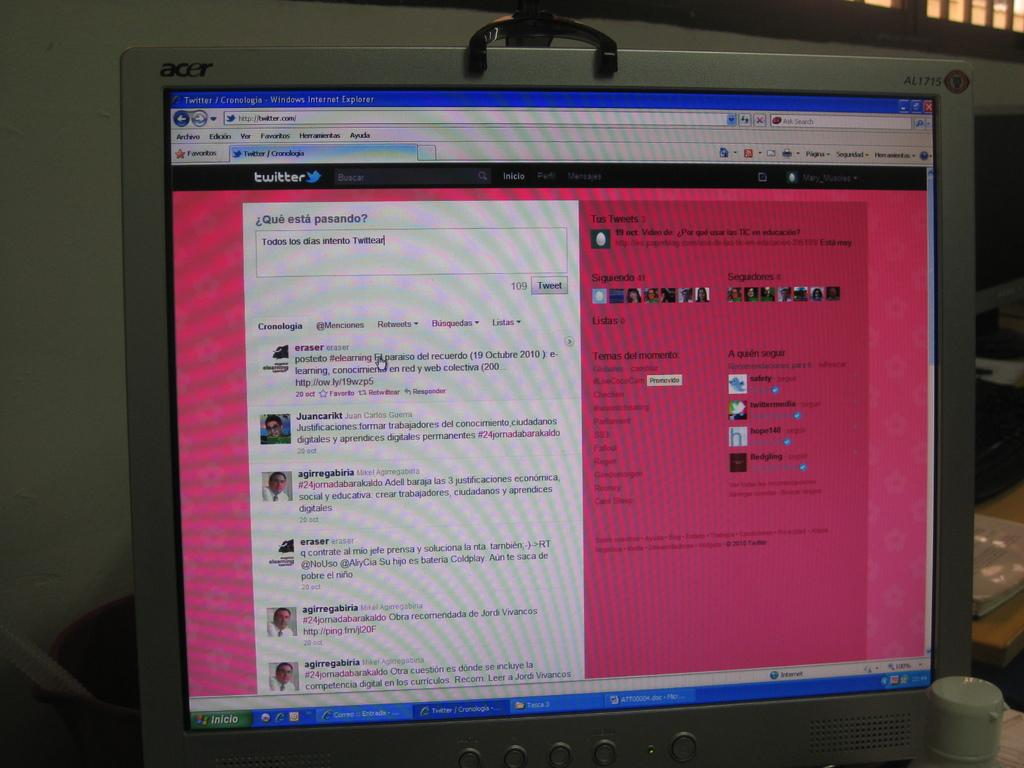<image>
Describe the image concisely. an acer computer screen open to a twitter page 